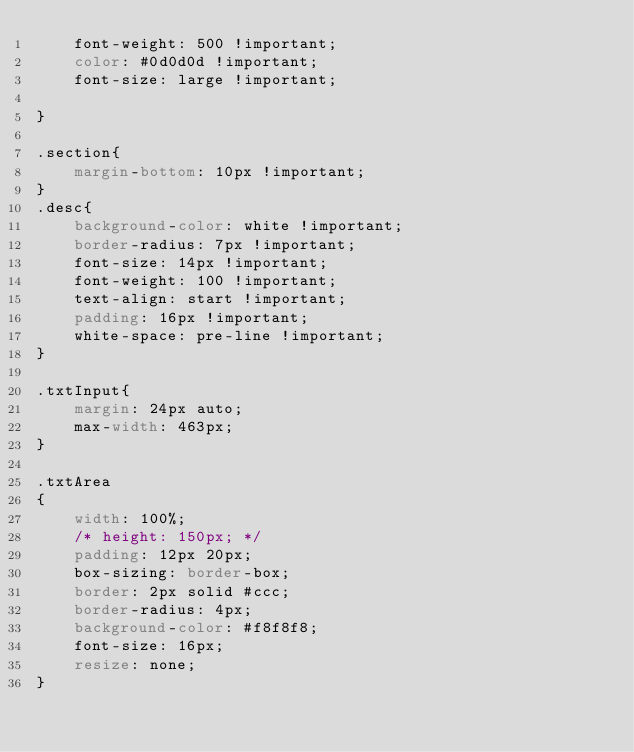Convert code to text. <code><loc_0><loc_0><loc_500><loc_500><_CSS_>    font-weight: 500 !important;
    color: #0d0d0d !important;
    font-size: large !important;

}

.section{
    margin-bottom: 10px !important;
}
.desc{
    background-color: white !important;
    border-radius: 7px !important;
    font-size: 14px !important;
    font-weight: 100 !important;
    text-align: start !important;
    padding: 16px !important;
    white-space: pre-line !important;
}

.txtInput{
    margin: 24px auto;
    max-width: 463px;
}

.txtArea
{
    width: 100%;
    /* height: 150px; */
    padding: 12px 20px;
    box-sizing: border-box;
    border: 2px solid #ccc;
    border-radius: 4px;
    background-color: #f8f8f8;
    font-size: 16px;
    resize: none;
}</code> 